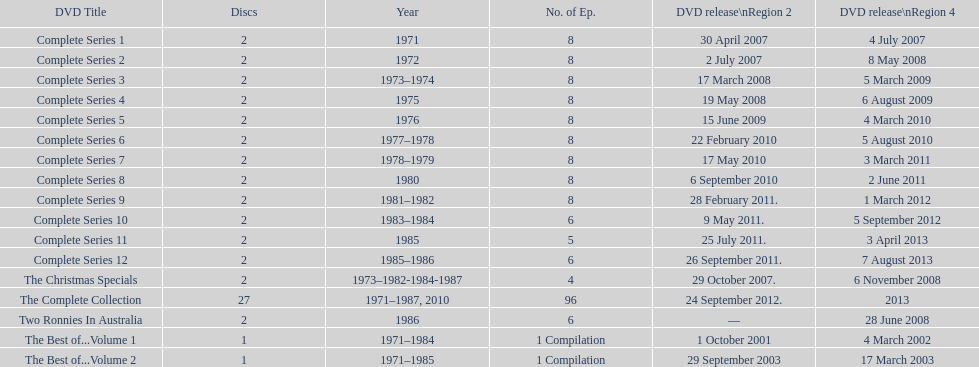What is the sum of episodes that came out in region 2 in the year 2007? 20. 